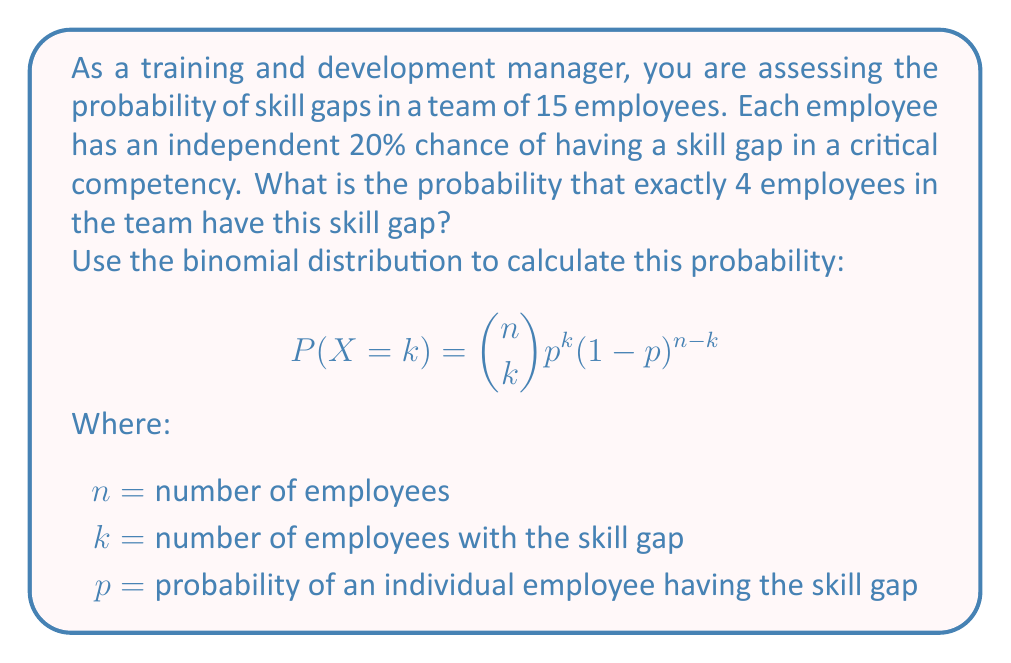Help me with this question. To solve this problem, we'll use the binomial distribution formula:

$$P(X = k) = \binom{n}{k} p^k (1-p)^{n-k}$$

Given:
$n = 15$ (total number of employees)
$k = 4$ (number of employees with the skill gap)
$p = 0.20$ (probability of an individual employee having the skill gap)

Step 1: Calculate the binomial coefficient $\binom{n}{k}$
$$\binom{15}{4} = \frac{15!}{4!(15-4)!} = \frac{15!}{4!11!} = 1365$$

Step 2: Calculate $p^k$
$$0.20^4 = 0.0016$$

Step 3: Calculate $(1-p)^{n-k}$
$$(1-0.20)^{15-4} = 0.80^{11} = 0.0861$$

Step 4: Multiply the results from steps 1, 2, and 3
$$1365 \times 0.0016 \times 0.0861 = 0.1880$$

Therefore, the probability of exactly 4 employees having the skill gap is approximately 0.1880 or 18.80%.
Answer: 0.1880 or 18.80% 